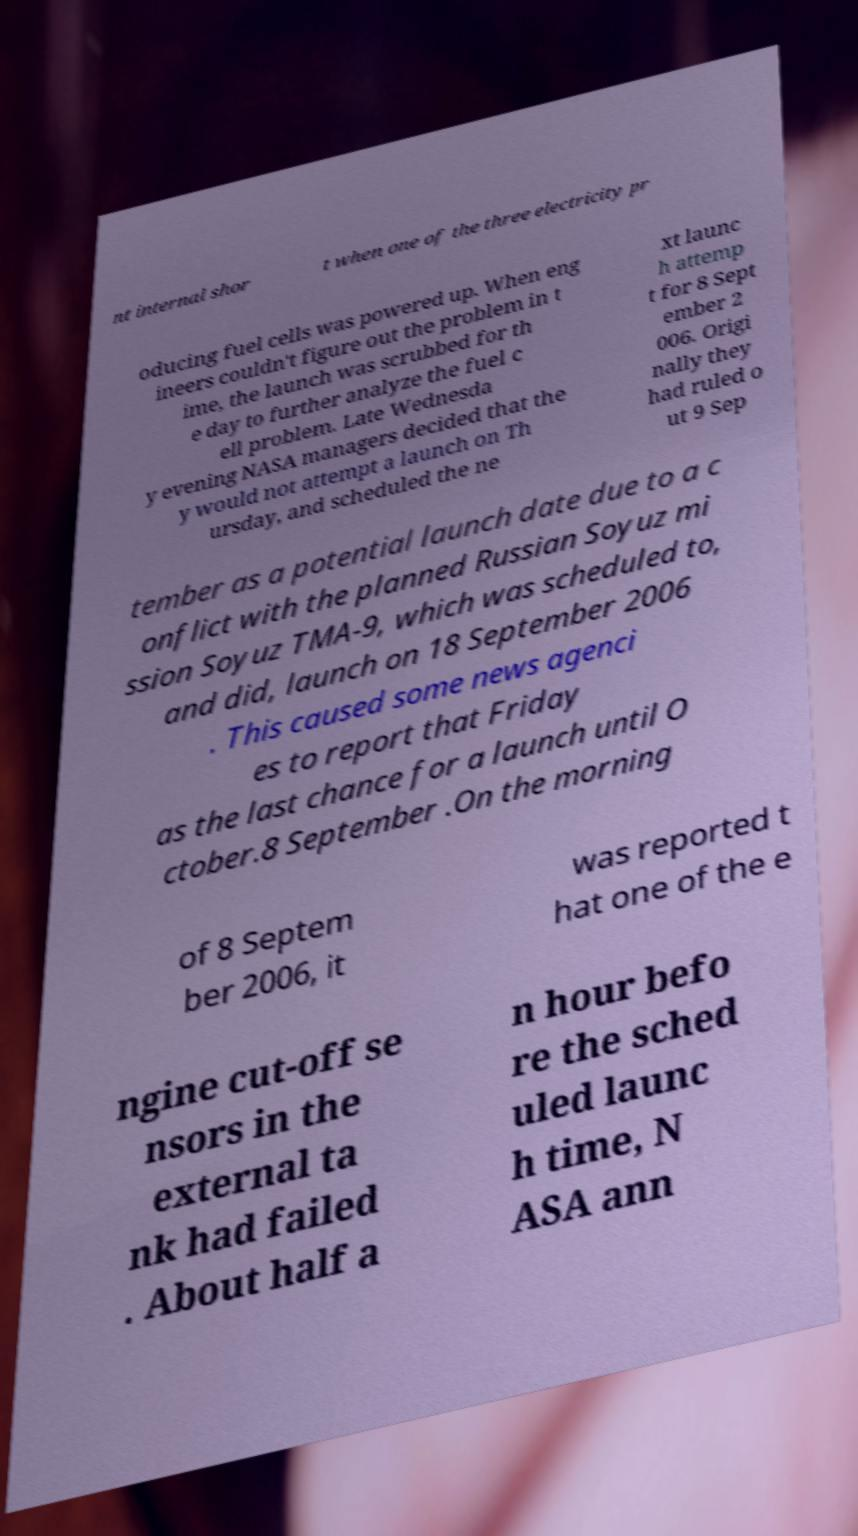What messages or text are displayed in this image? I need them in a readable, typed format. nt internal shor t when one of the three electricity pr oducing fuel cells was powered up. When eng ineers couldn't figure out the problem in t ime, the launch was scrubbed for th e day to further analyze the fuel c ell problem. Late Wednesda y evening NASA managers decided that the y would not attempt a launch on Th ursday, and scheduled the ne xt launc h attemp t for 8 Sept ember 2 006. Origi nally they had ruled o ut 9 Sep tember as a potential launch date due to a c onflict with the planned Russian Soyuz mi ssion Soyuz TMA-9, which was scheduled to, and did, launch on 18 September 2006 . This caused some news agenci es to report that Friday as the last chance for a launch until O ctober.8 September .On the morning of 8 Septem ber 2006, it was reported t hat one of the e ngine cut-off se nsors in the external ta nk had failed . About half a n hour befo re the sched uled launc h time, N ASA ann 